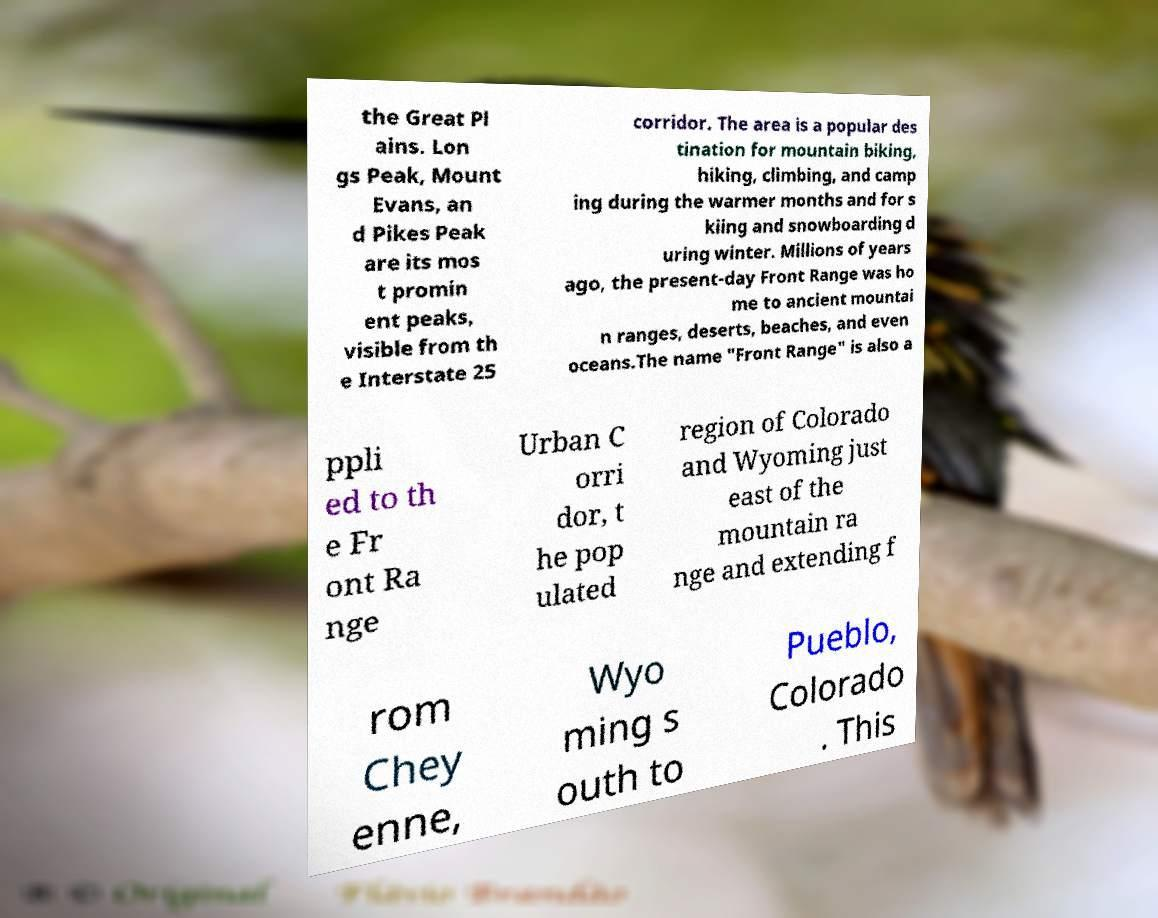For documentation purposes, I need the text within this image transcribed. Could you provide that? the Great Pl ains. Lon gs Peak, Mount Evans, an d Pikes Peak are its mos t promin ent peaks, visible from th e Interstate 25 corridor. The area is a popular des tination for mountain biking, hiking, climbing, and camp ing during the warmer months and for s kiing and snowboarding d uring winter. Millions of years ago, the present-day Front Range was ho me to ancient mountai n ranges, deserts, beaches, and even oceans.The name "Front Range" is also a ppli ed to th e Fr ont Ra nge Urban C orri dor, t he pop ulated region of Colorado and Wyoming just east of the mountain ra nge and extending f rom Chey enne, Wyo ming s outh to Pueblo, Colorado . This 